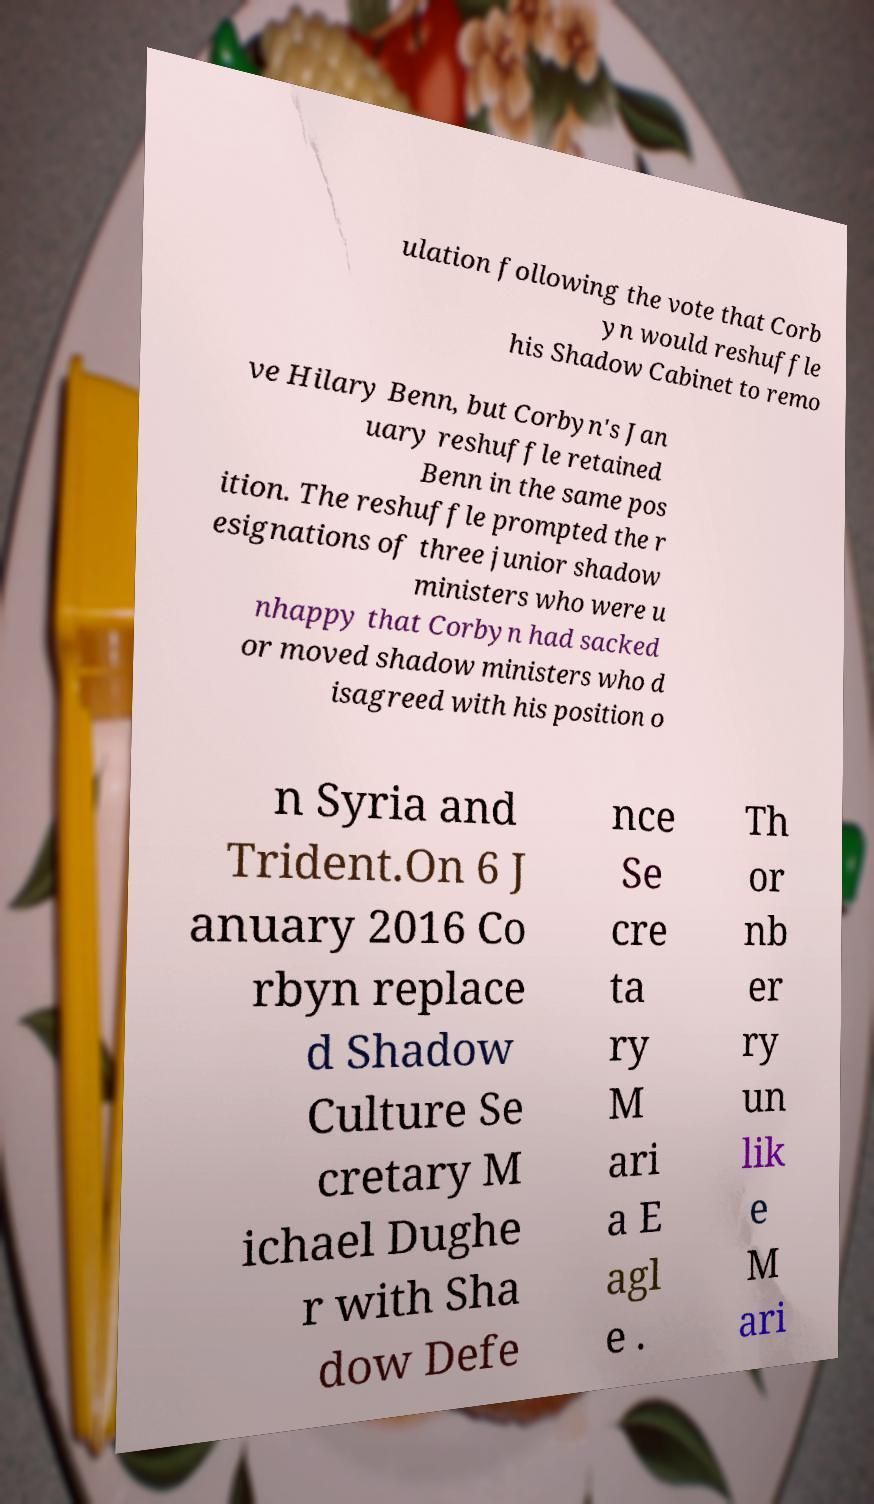Please read and relay the text visible in this image. What does it say? ulation following the vote that Corb yn would reshuffle his Shadow Cabinet to remo ve Hilary Benn, but Corbyn's Jan uary reshuffle retained Benn in the same pos ition. The reshuffle prompted the r esignations of three junior shadow ministers who were u nhappy that Corbyn had sacked or moved shadow ministers who d isagreed with his position o n Syria and Trident.On 6 J anuary 2016 Co rbyn replace d Shadow Culture Se cretary M ichael Dughe r with Sha dow Defe nce Se cre ta ry M ari a E agl e . Th or nb er ry un lik e M ari 